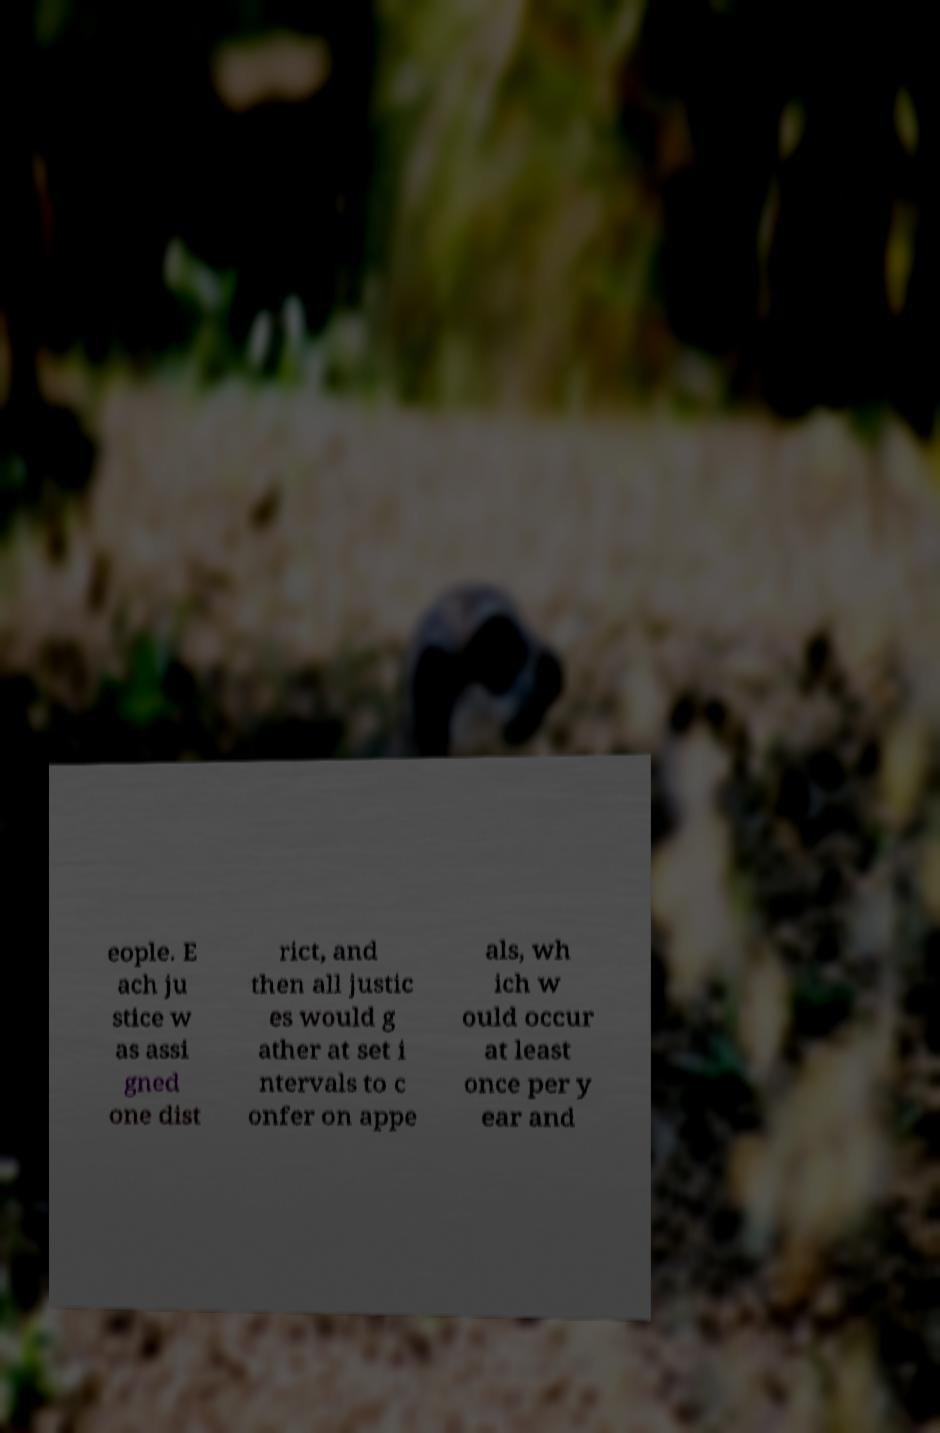For documentation purposes, I need the text within this image transcribed. Could you provide that? eople. E ach ju stice w as assi gned one dist rict, and then all justic es would g ather at set i ntervals to c onfer on appe als, wh ich w ould occur at least once per y ear and 